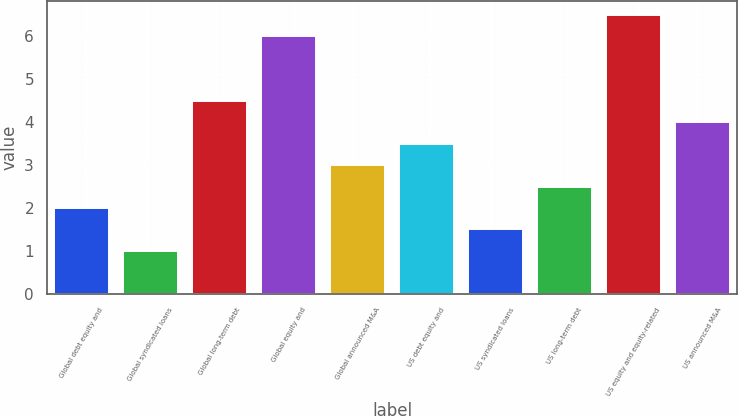Convert chart. <chart><loc_0><loc_0><loc_500><loc_500><bar_chart><fcel>Global debt equity and<fcel>Global syndicated loans<fcel>Global long-term debt<fcel>Global equity and<fcel>Global announced M&A<fcel>US debt equity and<fcel>US syndicated loans<fcel>US long-term debt<fcel>US equity and equity-related<fcel>US announced M&A<nl><fcel>2<fcel>1<fcel>4.5<fcel>6<fcel>3<fcel>3.5<fcel>1.5<fcel>2.5<fcel>6.5<fcel>4<nl></chart> 